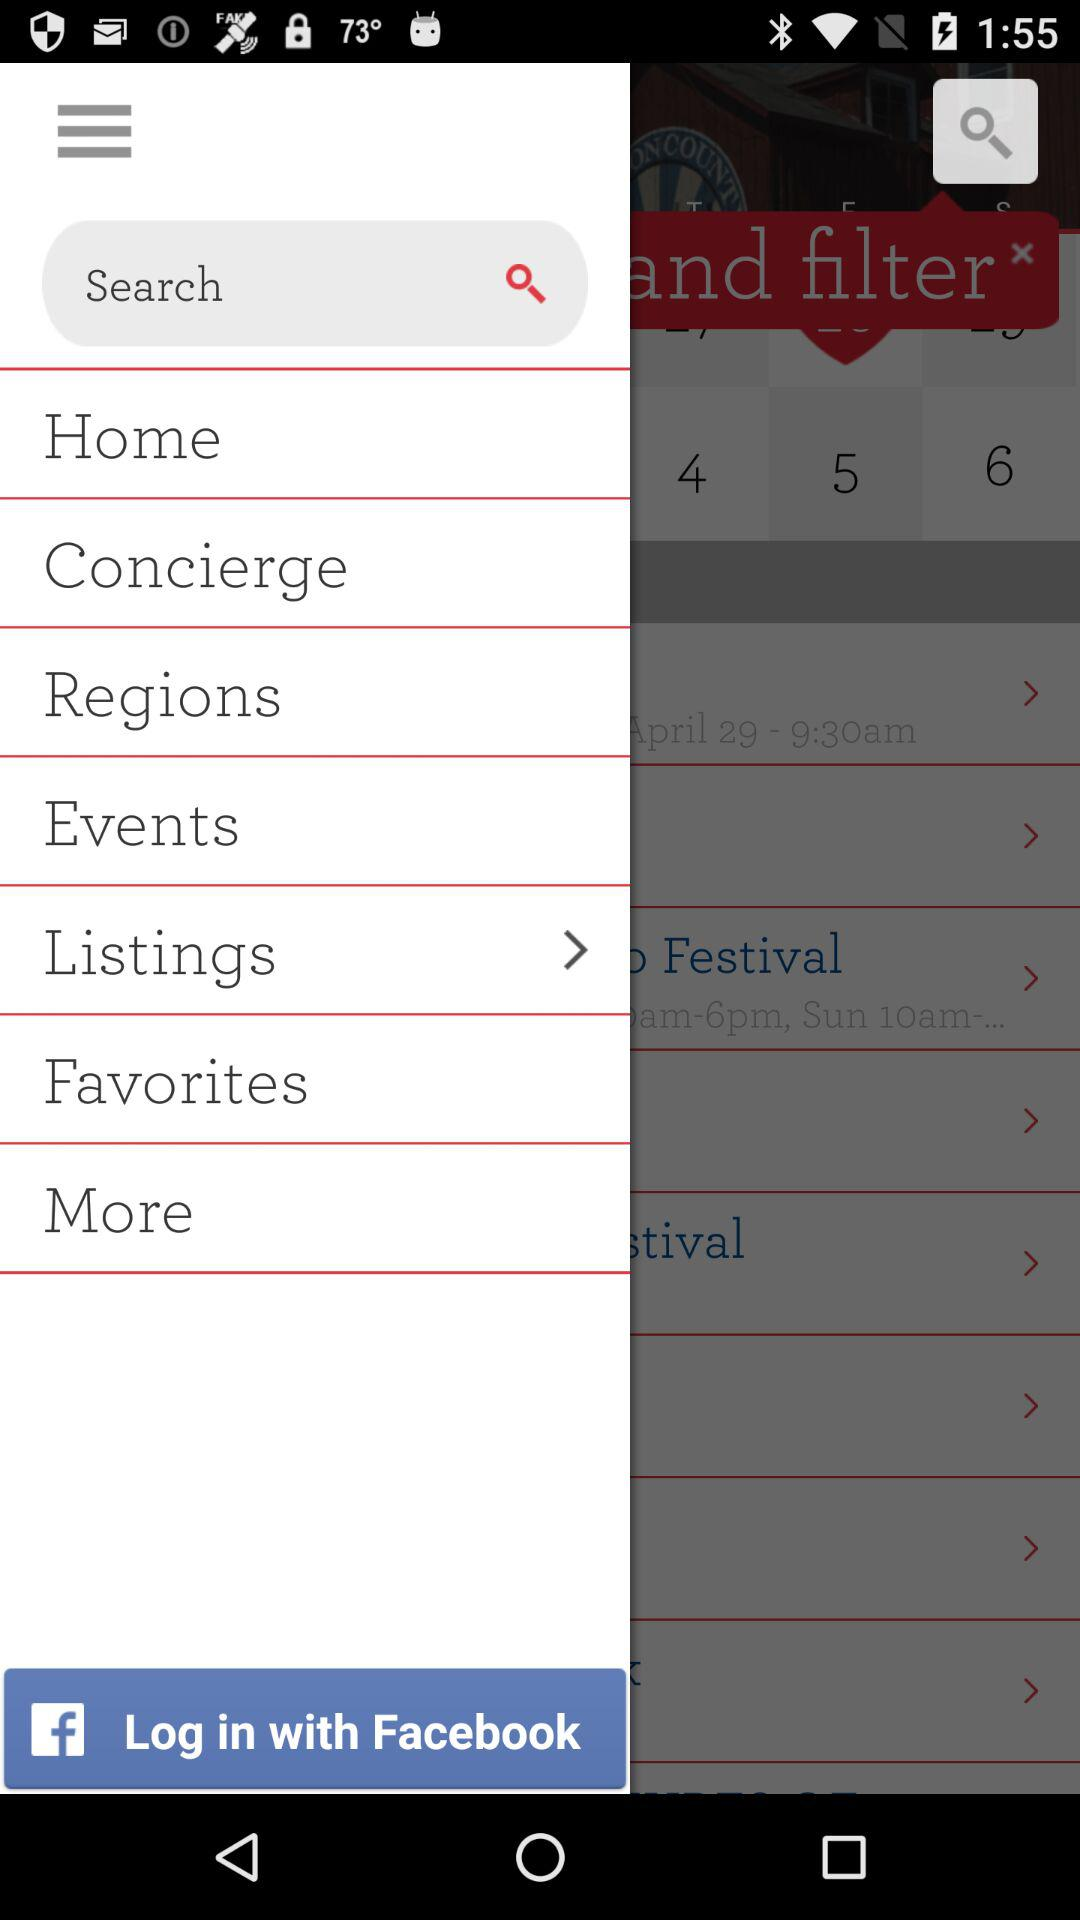What are the options available for logging in? The available option is "Facebook". 